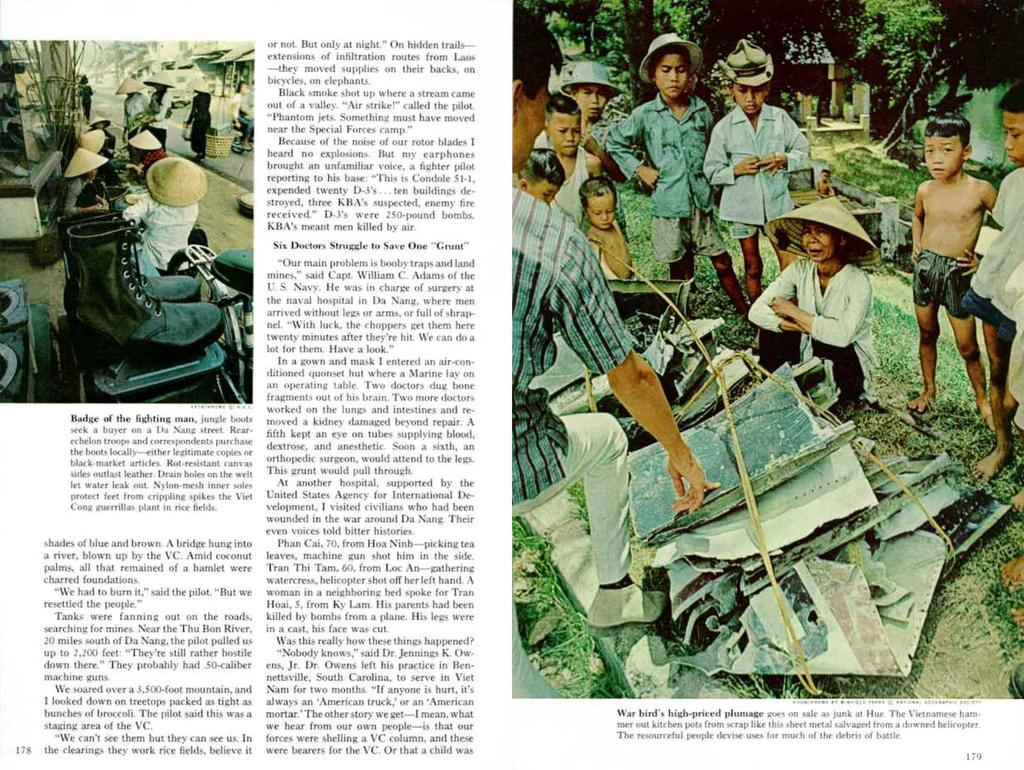What type of content is shown in the image? The image is of an article. What can be found within the article? There are images and text present in the article. What subjects are depicted in the images within the article? The images within the article depict people, trees, boots, grass, and hats. What type of objects are shown in the images within the article? The images within the article depict objects. What holiday is being celebrated in the images within the article? There is no indication of a holiday being celebrated in the images within the article. How many times do the ducks roll in the images within the article? There are no ducks present in the images within the article. 